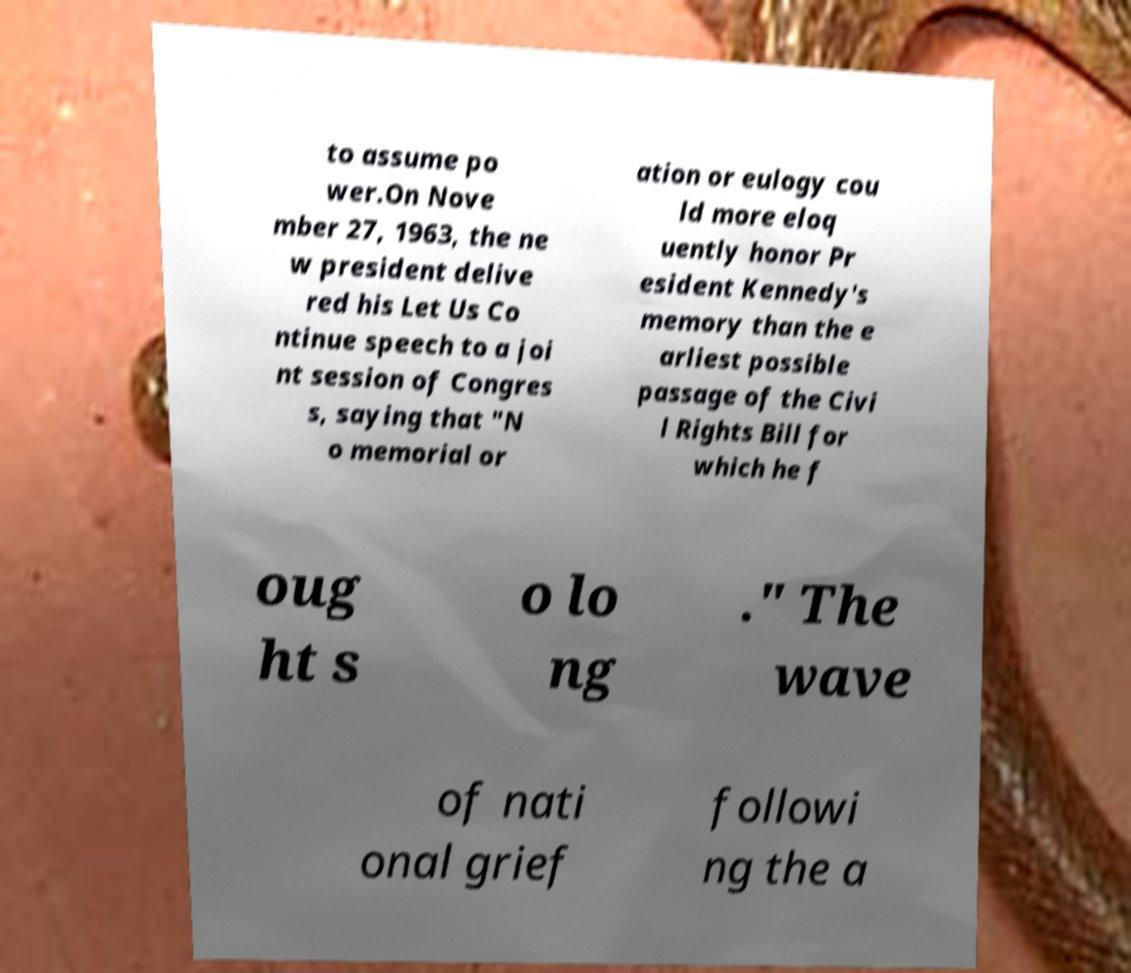Can you accurately transcribe the text from the provided image for me? to assume po wer.On Nove mber 27, 1963, the ne w president delive red his Let Us Co ntinue speech to a joi nt session of Congres s, saying that "N o memorial or ation or eulogy cou ld more eloq uently honor Pr esident Kennedy's memory than the e arliest possible passage of the Civi l Rights Bill for which he f oug ht s o lo ng ." The wave of nati onal grief followi ng the a 